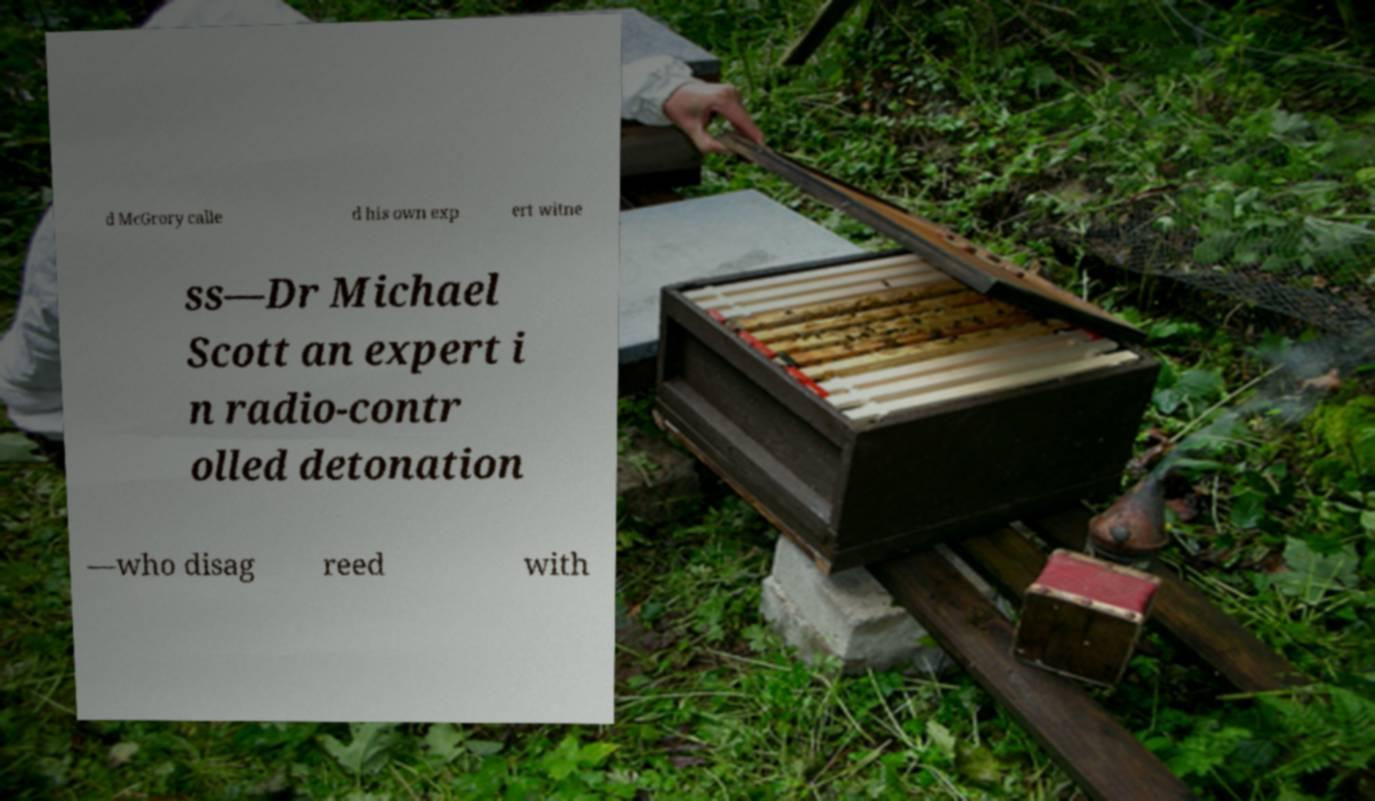What messages or text are displayed in this image? I need them in a readable, typed format. d McGrory calle d his own exp ert witne ss—Dr Michael Scott an expert i n radio-contr olled detonation —who disag reed with 